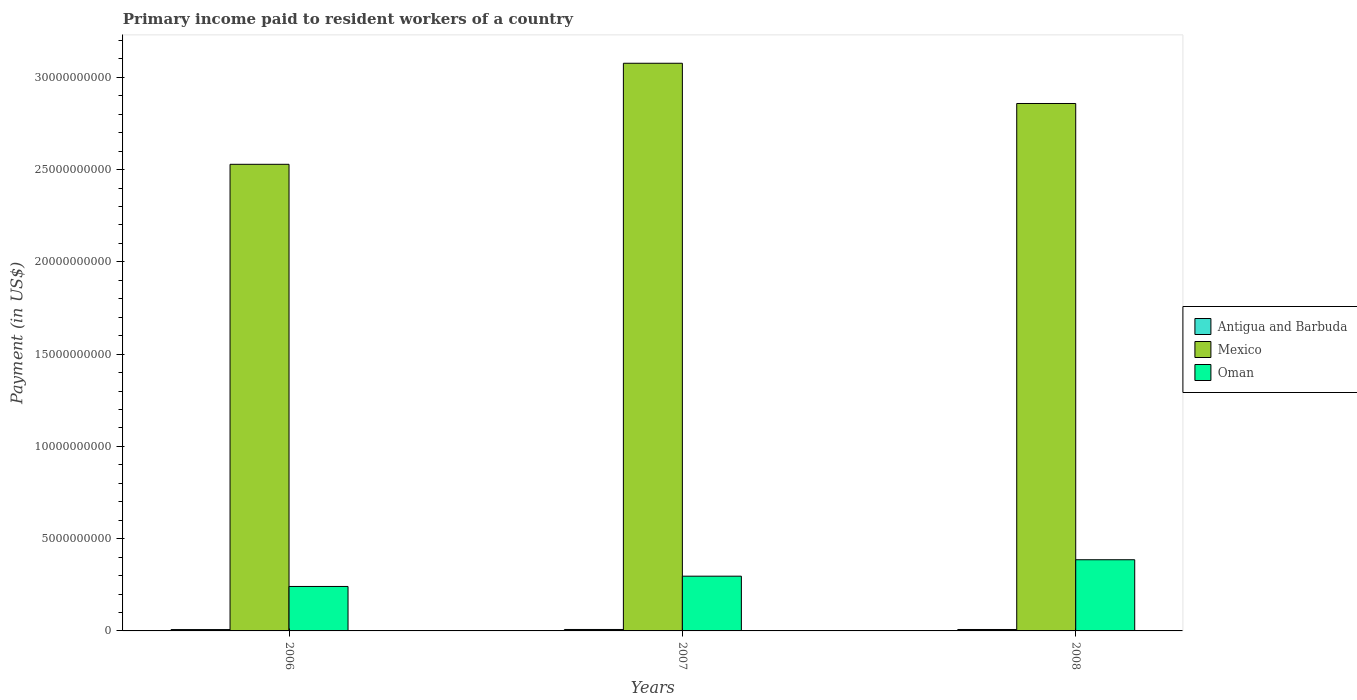How many different coloured bars are there?
Give a very brief answer. 3. Are the number of bars per tick equal to the number of legend labels?
Offer a terse response. Yes. In how many cases, is the number of bars for a given year not equal to the number of legend labels?
Your response must be concise. 0. What is the amount paid to workers in Oman in 2008?
Make the answer very short. 3.86e+09. Across all years, what is the maximum amount paid to workers in Mexico?
Your answer should be very brief. 3.08e+1. Across all years, what is the minimum amount paid to workers in Oman?
Your answer should be compact. 2.41e+09. In which year was the amount paid to workers in Antigua and Barbuda maximum?
Provide a succinct answer. 2007. What is the total amount paid to workers in Mexico in the graph?
Provide a short and direct response. 8.46e+1. What is the difference between the amount paid to workers in Mexico in 2006 and that in 2008?
Provide a short and direct response. -3.30e+09. What is the difference between the amount paid to workers in Mexico in 2008 and the amount paid to workers in Antigua and Barbuda in 2006?
Your answer should be compact. 2.85e+1. What is the average amount paid to workers in Mexico per year?
Keep it short and to the point. 2.82e+1. In the year 2006, what is the difference between the amount paid to workers in Antigua and Barbuda and amount paid to workers in Oman?
Keep it short and to the point. -2.34e+09. In how many years, is the amount paid to workers in Antigua and Barbuda greater than 2000000000 US$?
Give a very brief answer. 0. What is the ratio of the amount paid to workers in Antigua and Barbuda in 2007 to that in 2008?
Your response must be concise. 1.02. Is the difference between the amount paid to workers in Antigua and Barbuda in 2006 and 2007 greater than the difference between the amount paid to workers in Oman in 2006 and 2007?
Keep it short and to the point. Yes. What is the difference between the highest and the second highest amount paid to workers in Mexico?
Offer a terse response. 2.18e+09. What is the difference between the highest and the lowest amount paid to workers in Mexico?
Make the answer very short. 5.48e+09. In how many years, is the amount paid to workers in Oman greater than the average amount paid to workers in Oman taken over all years?
Make the answer very short. 1. What does the 1st bar from the left in 2008 represents?
Offer a terse response. Antigua and Barbuda. What does the 1st bar from the right in 2006 represents?
Make the answer very short. Oman. Is it the case that in every year, the sum of the amount paid to workers in Antigua and Barbuda and amount paid to workers in Oman is greater than the amount paid to workers in Mexico?
Your answer should be compact. No. Are all the bars in the graph horizontal?
Give a very brief answer. No. How many years are there in the graph?
Your answer should be compact. 3. Does the graph contain any zero values?
Give a very brief answer. No. Does the graph contain grids?
Keep it short and to the point. No. Where does the legend appear in the graph?
Ensure brevity in your answer.  Center right. How many legend labels are there?
Your answer should be very brief. 3. How are the legend labels stacked?
Your answer should be compact. Vertical. What is the title of the graph?
Your answer should be very brief. Primary income paid to resident workers of a country. Does "Japan" appear as one of the legend labels in the graph?
Provide a succinct answer. No. What is the label or title of the X-axis?
Offer a terse response. Years. What is the label or title of the Y-axis?
Provide a succinct answer. Payment (in US$). What is the Payment (in US$) of Antigua and Barbuda in 2006?
Your answer should be compact. 7.35e+07. What is the Payment (in US$) of Mexico in 2006?
Ensure brevity in your answer.  2.53e+1. What is the Payment (in US$) of Oman in 2006?
Offer a very short reply. 2.41e+09. What is the Payment (in US$) in Antigua and Barbuda in 2007?
Give a very brief answer. 7.85e+07. What is the Payment (in US$) of Mexico in 2007?
Ensure brevity in your answer.  3.08e+1. What is the Payment (in US$) in Oman in 2007?
Give a very brief answer. 2.97e+09. What is the Payment (in US$) in Antigua and Barbuda in 2008?
Your answer should be compact. 7.72e+07. What is the Payment (in US$) of Mexico in 2008?
Ensure brevity in your answer.  2.86e+1. What is the Payment (in US$) in Oman in 2008?
Your answer should be compact. 3.86e+09. Across all years, what is the maximum Payment (in US$) in Antigua and Barbuda?
Offer a terse response. 7.85e+07. Across all years, what is the maximum Payment (in US$) in Mexico?
Provide a short and direct response. 3.08e+1. Across all years, what is the maximum Payment (in US$) of Oman?
Make the answer very short. 3.86e+09. Across all years, what is the minimum Payment (in US$) of Antigua and Barbuda?
Give a very brief answer. 7.35e+07. Across all years, what is the minimum Payment (in US$) in Mexico?
Keep it short and to the point. 2.53e+1. Across all years, what is the minimum Payment (in US$) in Oman?
Keep it short and to the point. 2.41e+09. What is the total Payment (in US$) in Antigua and Barbuda in the graph?
Keep it short and to the point. 2.29e+08. What is the total Payment (in US$) in Mexico in the graph?
Your answer should be compact. 8.46e+1. What is the total Payment (in US$) of Oman in the graph?
Your response must be concise. 9.23e+09. What is the difference between the Payment (in US$) in Antigua and Barbuda in 2006 and that in 2007?
Provide a succinct answer. -5.01e+06. What is the difference between the Payment (in US$) in Mexico in 2006 and that in 2007?
Your answer should be compact. -5.48e+09. What is the difference between the Payment (in US$) of Oman in 2006 and that in 2007?
Provide a short and direct response. -5.57e+08. What is the difference between the Payment (in US$) in Antigua and Barbuda in 2006 and that in 2008?
Offer a very short reply. -3.74e+06. What is the difference between the Payment (in US$) of Mexico in 2006 and that in 2008?
Keep it short and to the point. -3.30e+09. What is the difference between the Payment (in US$) in Oman in 2006 and that in 2008?
Offer a very short reply. -1.45e+09. What is the difference between the Payment (in US$) in Antigua and Barbuda in 2007 and that in 2008?
Provide a short and direct response. 1.27e+06. What is the difference between the Payment (in US$) in Mexico in 2007 and that in 2008?
Provide a succinct answer. 2.18e+09. What is the difference between the Payment (in US$) in Oman in 2007 and that in 2008?
Your answer should be very brief. -8.91e+08. What is the difference between the Payment (in US$) in Antigua and Barbuda in 2006 and the Payment (in US$) in Mexico in 2007?
Give a very brief answer. -3.07e+1. What is the difference between the Payment (in US$) in Antigua and Barbuda in 2006 and the Payment (in US$) in Oman in 2007?
Your response must be concise. -2.89e+09. What is the difference between the Payment (in US$) in Mexico in 2006 and the Payment (in US$) in Oman in 2007?
Your answer should be compact. 2.23e+1. What is the difference between the Payment (in US$) in Antigua and Barbuda in 2006 and the Payment (in US$) in Mexico in 2008?
Your answer should be compact. -2.85e+1. What is the difference between the Payment (in US$) in Antigua and Barbuda in 2006 and the Payment (in US$) in Oman in 2008?
Give a very brief answer. -3.78e+09. What is the difference between the Payment (in US$) of Mexico in 2006 and the Payment (in US$) of Oman in 2008?
Keep it short and to the point. 2.14e+1. What is the difference between the Payment (in US$) of Antigua and Barbuda in 2007 and the Payment (in US$) of Mexico in 2008?
Provide a succinct answer. -2.85e+1. What is the difference between the Payment (in US$) of Antigua and Barbuda in 2007 and the Payment (in US$) of Oman in 2008?
Offer a terse response. -3.78e+09. What is the difference between the Payment (in US$) in Mexico in 2007 and the Payment (in US$) in Oman in 2008?
Provide a succinct answer. 2.69e+1. What is the average Payment (in US$) in Antigua and Barbuda per year?
Make the answer very short. 7.64e+07. What is the average Payment (in US$) of Mexico per year?
Ensure brevity in your answer.  2.82e+1. What is the average Payment (in US$) of Oman per year?
Provide a short and direct response. 3.08e+09. In the year 2006, what is the difference between the Payment (in US$) of Antigua and Barbuda and Payment (in US$) of Mexico?
Your answer should be compact. -2.52e+1. In the year 2006, what is the difference between the Payment (in US$) of Antigua and Barbuda and Payment (in US$) of Oman?
Make the answer very short. -2.34e+09. In the year 2006, what is the difference between the Payment (in US$) of Mexico and Payment (in US$) of Oman?
Provide a succinct answer. 2.29e+1. In the year 2007, what is the difference between the Payment (in US$) in Antigua and Barbuda and Payment (in US$) in Mexico?
Make the answer very short. -3.07e+1. In the year 2007, what is the difference between the Payment (in US$) in Antigua and Barbuda and Payment (in US$) in Oman?
Give a very brief answer. -2.89e+09. In the year 2007, what is the difference between the Payment (in US$) in Mexico and Payment (in US$) in Oman?
Give a very brief answer. 2.78e+1. In the year 2008, what is the difference between the Payment (in US$) of Antigua and Barbuda and Payment (in US$) of Mexico?
Ensure brevity in your answer.  -2.85e+1. In the year 2008, what is the difference between the Payment (in US$) in Antigua and Barbuda and Payment (in US$) in Oman?
Provide a short and direct response. -3.78e+09. In the year 2008, what is the difference between the Payment (in US$) of Mexico and Payment (in US$) of Oman?
Offer a very short reply. 2.47e+1. What is the ratio of the Payment (in US$) of Antigua and Barbuda in 2006 to that in 2007?
Make the answer very short. 0.94. What is the ratio of the Payment (in US$) of Mexico in 2006 to that in 2007?
Make the answer very short. 0.82. What is the ratio of the Payment (in US$) of Oman in 2006 to that in 2007?
Your answer should be very brief. 0.81. What is the ratio of the Payment (in US$) of Antigua and Barbuda in 2006 to that in 2008?
Offer a very short reply. 0.95. What is the ratio of the Payment (in US$) of Mexico in 2006 to that in 2008?
Your answer should be very brief. 0.88. What is the ratio of the Payment (in US$) in Oman in 2006 to that in 2008?
Offer a very short reply. 0.62. What is the ratio of the Payment (in US$) in Antigua and Barbuda in 2007 to that in 2008?
Your answer should be compact. 1.02. What is the ratio of the Payment (in US$) of Mexico in 2007 to that in 2008?
Offer a very short reply. 1.08. What is the ratio of the Payment (in US$) of Oman in 2007 to that in 2008?
Ensure brevity in your answer.  0.77. What is the difference between the highest and the second highest Payment (in US$) of Antigua and Barbuda?
Your answer should be very brief. 1.27e+06. What is the difference between the highest and the second highest Payment (in US$) of Mexico?
Offer a very short reply. 2.18e+09. What is the difference between the highest and the second highest Payment (in US$) of Oman?
Make the answer very short. 8.91e+08. What is the difference between the highest and the lowest Payment (in US$) in Antigua and Barbuda?
Your answer should be compact. 5.01e+06. What is the difference between the highest and the lowest Payment (in US$) of Mexico?
Offer a very short reply. 5.48e+09. What is the difference between the highest and the lowest Payment (in US$) in Oman?
Make the answer very short. 1.45e+09. 